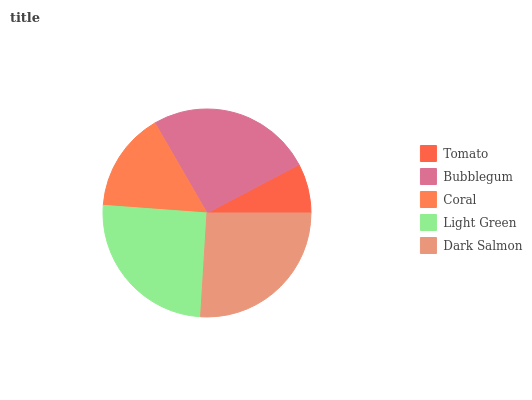Is Tomato the minimum?
Answer yes or no. Yes. Is Dark Salmon the maximum?
Answer yes or no. Yes. Is Bubblegum the minimum?
Answer yes or no. No. Is Bubblegum the maximum?
Answer yes or no. No. Is Bubblegum greater than Tomato?
Answer yes or no. Yes. Is Tomato less than Bubblegum?
Answer yes or no. Yes. Is Tomato greater than Bubblegum?
Answer yes or no. No. Is Bubblegum less than Tomato?
Answer yes or no. No. Is Light Green the high median?
Answer yes or no. Yes. Is Light Green the low median?
Answer yes or no. Yes. Is Coral the high median?
Answer yes or no. No. Is Tomato the low median?
Answer yes or no. No. 